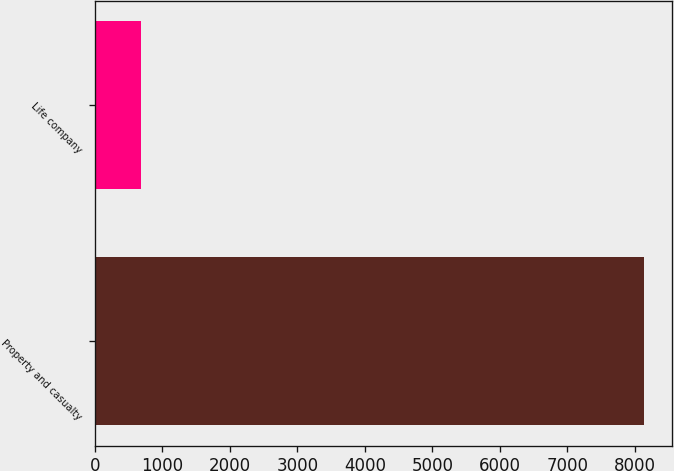Convert chart. <chart><loc_0><loc_0><loc_500><loc_500><bar_chart><fcel>Property and casualty<fcel>Life company<nl><fcel>8137<fcel>687<nl></chart> 